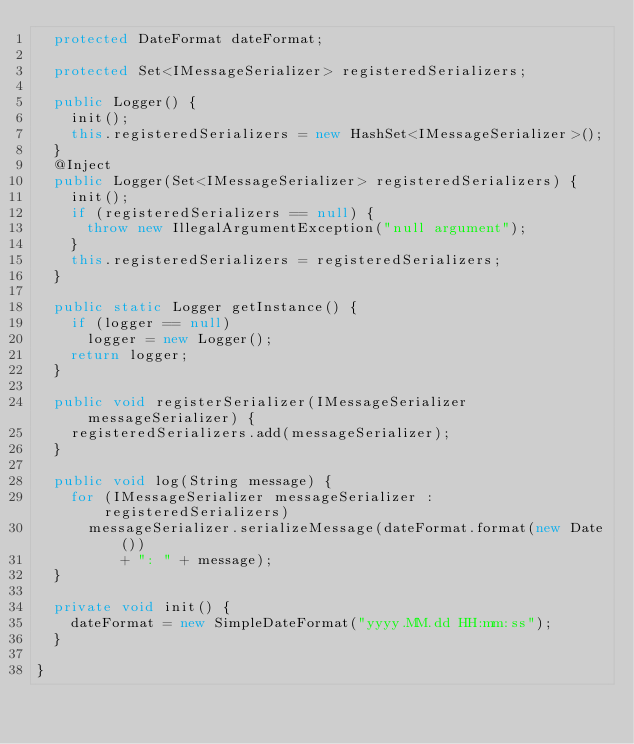<code> <loc_0><loc_0><loc_500><loc_500><_Java_>	protected DateFormat dateFormat;

	protected Set<IMessageSerializer> registeredSerializers;

	public Logger() {
		init();
		this.registeredSerializers = new HashSet<IMessageSerializer>();
	}
	@Inject
	public Logger(Set<IMessageSerializer> registeredSerializers) {
		init();
		if (registeredSerializers == null) {
			throw new IllegalArgumentException("null argument");
		}
		this.registeredSerializers = registeredSerializers;
	}

	public static Logger getInstance() {
		if (logger == null)
			logger = new Logger();
		return logger;
	}

	public void registerSerializer(IMessageSerializer messageSerializer) {
		registeredSerializers.add(messageSerializer);
	}

	public void log(String message) {
		for (IMessageSerializer messageSerializer : registeredSerializers)
			messageSerializer.serializeMessage(dateFormat.format(new Date())
					+ ": " + message);
	}

	private void init() {
		dateFormat = new SimpleDateFormat("yyyy.MM.dd HH:mm:ss");
	}

}
</code> 